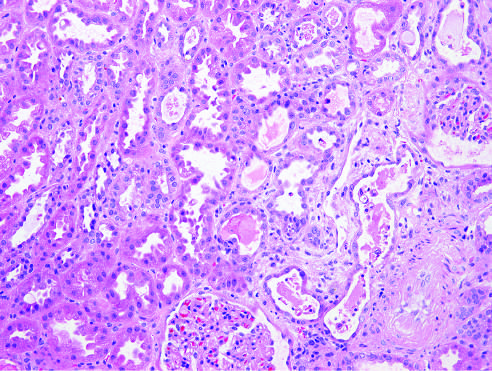cute tubular epithelial cell injury with blebbing at the luminal pole , detachment of tubular cells from whose underlying basement membranes , and granular casts?
Answer the question using a single word or phrase. Their 